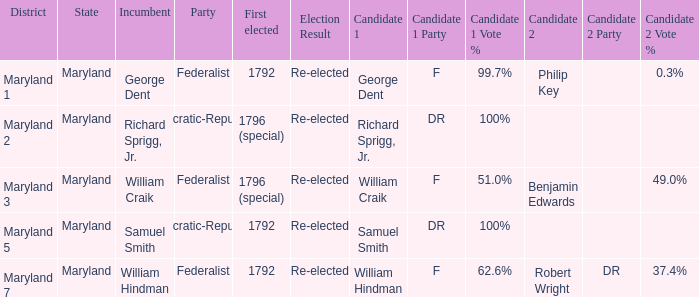What is the party when the current officeholder is samuel smith? Democratic-Republican. 